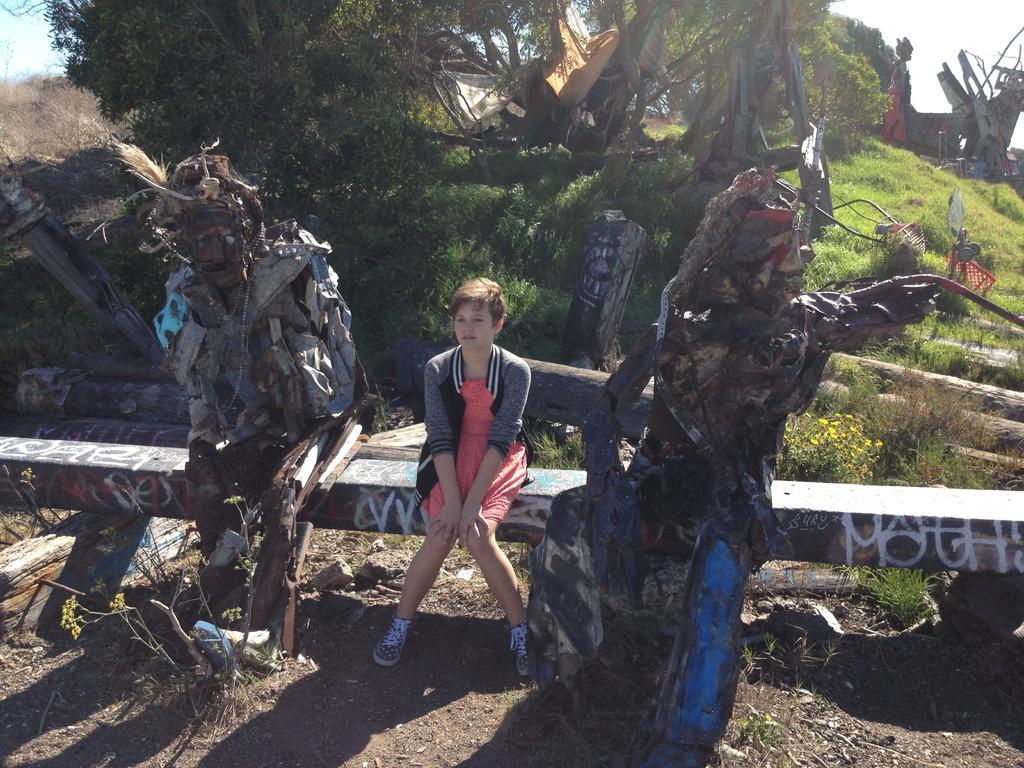What type of objects can be seen in the image? There are statues in the image. Can you describe the person's position in the image? There is a person sitting on a pole in the image. What type of vegetation is present in the image? There are trees and grass in the image. What material is visible in the image? There is wood in the image. Are there any other objects in the image besides the statues and the person on the pole? Yes, there are other objects in the image. What can be seen in the background of the image? The sky is visible in the background of the image. How many babies are crawling on the page in the image? There are no babies or pages present in the image. What type of line is connecting the statues in the image? There is no line connecting the statues in the image. 